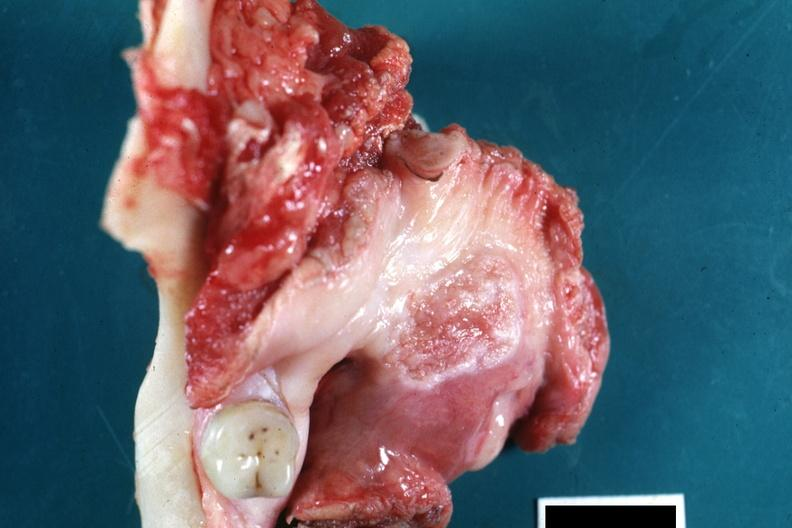what is present?
Answer the question using a single word or phrase. Squamous cell carcinoma 